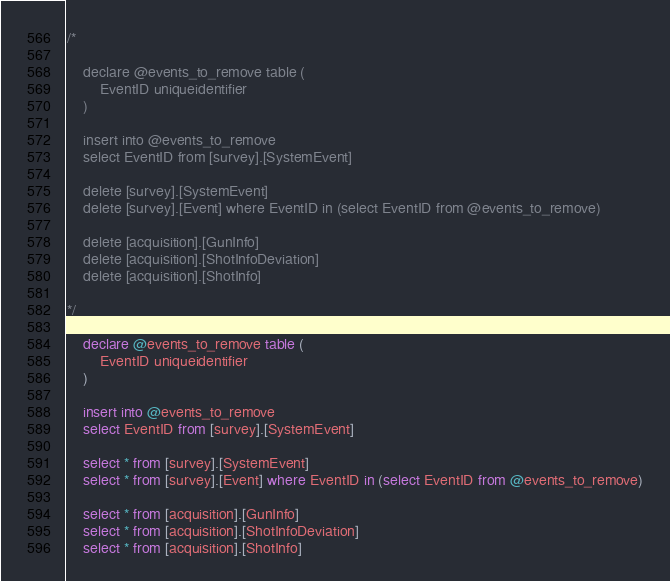<code> <loc_0><loc_0><loc_500><loc_500><_SQL_>/*

	declare @events_to_remove table (
		EventID uniqueidentifier 
	)

	insert into @events_to_remove
	select EventID from [survey].[SystemEvent]

	delete [survey].[SystemEvent]
	delete [survey].[Event] where EventID in (select EventID from @events_to_remove)

	delete [acquisition].[GunInfo]
	delete [acquisition].[ShotInfoDeviation]
	delete [acquisition].[ShotInfo]

*/

	declare @events_to_remove table (
		EventID uniqueidentifier 
	)

	insert into @events_to_remove
	select EventID from [survey].[SystemEvent]

	select * from [survey].[SystemEvent]
	select * from [survey].[Event] where EventID in (select EventID from @events_to_remove)

	select * from [acquisition].[GunInfo]
	select * from [acquisition].[ShotInfoDeviation]
	select * from [acquisition].[ShotInfo]</code> 